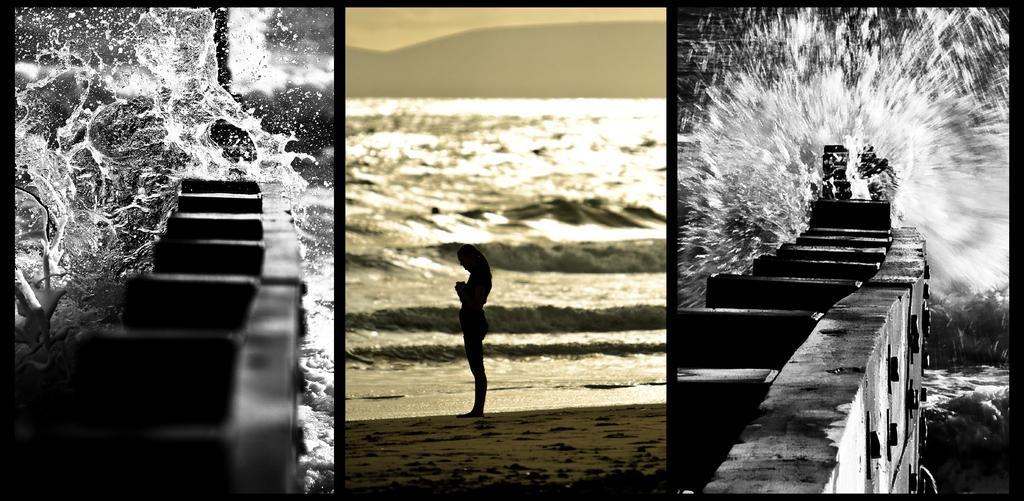In one or two sentences, can you explain what this image depicts? This is a collage of three images where we can see, there is one woman standing on the beach area in the middle of this image. There is some water on the bridge as we can see on the left side of this image and right side of this image as well. 